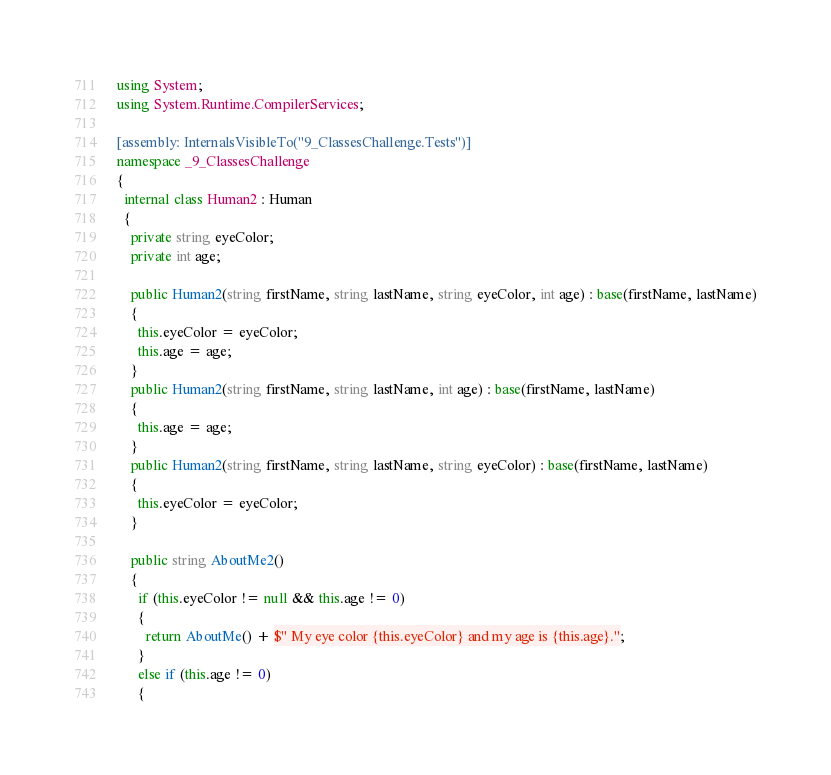<code> <loc_0><loc_0><loc_500><loc_500><_C#_>using System;
using System.Runtime.CompilerServices;

[assembly: InternalsVisibleTo("9_ClassesChallenge.Tests")]
namespace _9_ClassesChallenge
{
  internal class Human2 : Human
  {
    private string eyeColor;
    private int age;

    public Human2(string firstName, string lastName, string eyeColor, int age) : base(firstName, lastName)
    {
      this.eyeColor = eyeColor;
      this.age = age;
    }
    public Human2(string firstName, string lastName, int age) : base(firstName, lastName)
    {
      this.age = age;
    }
    public Human2(string firstName, string lastName, string eyeColor) : base(firstName, lastName)
    {
      this.eyeColor = eyeColor;
    }

    public string AboutMe2()
    {
      if (this.eyeColor != null && this.age != 0)
      {
        return AboutMe() + $" My eye color {this.eyeColor} and my age is {this.age}.";
      }
      else if (this.age != 0)
      {</code> 